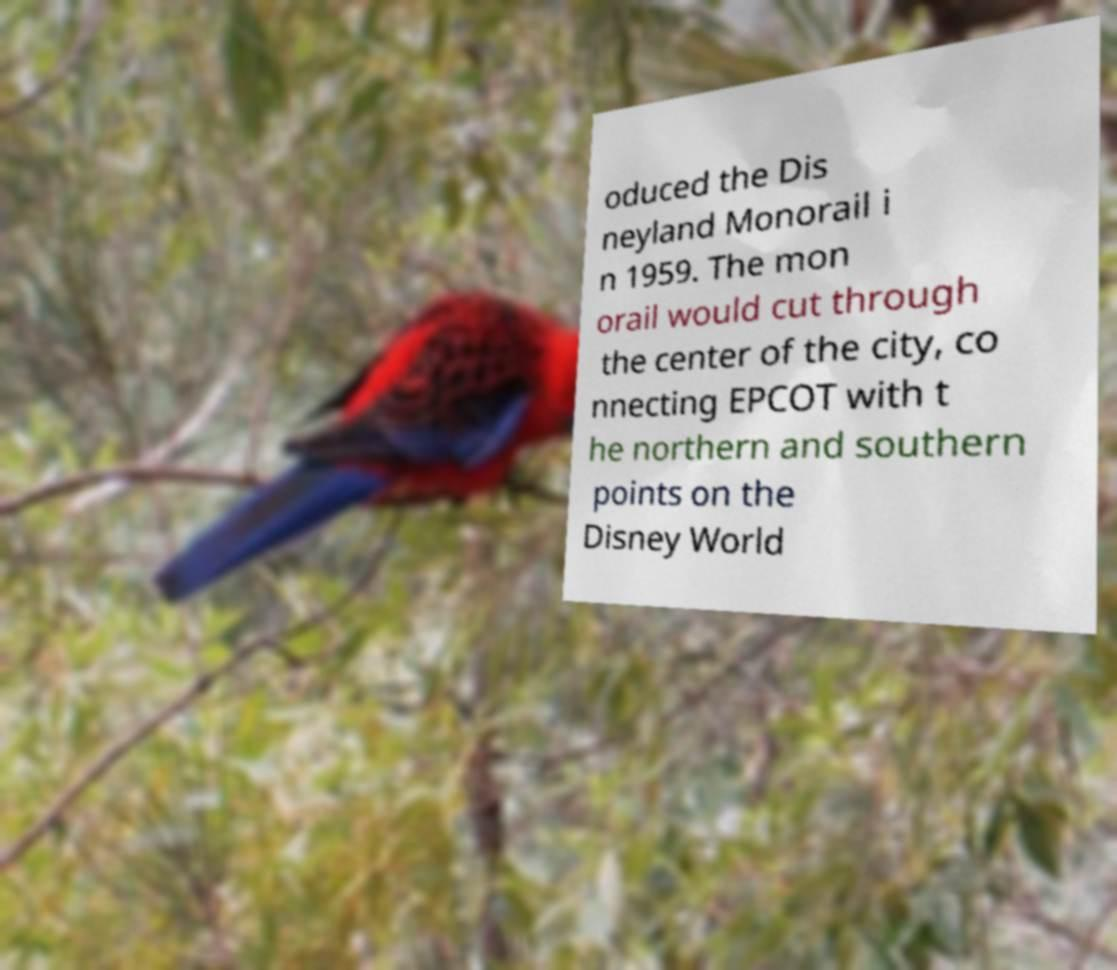Can you accurately transcribe the text from the provided image for me? oduced the Dis neyland Monorail i n 1959. The mon orail would cut through the center of the city, co nnecting EPCOT with t he northern and southern points on the Disney World 